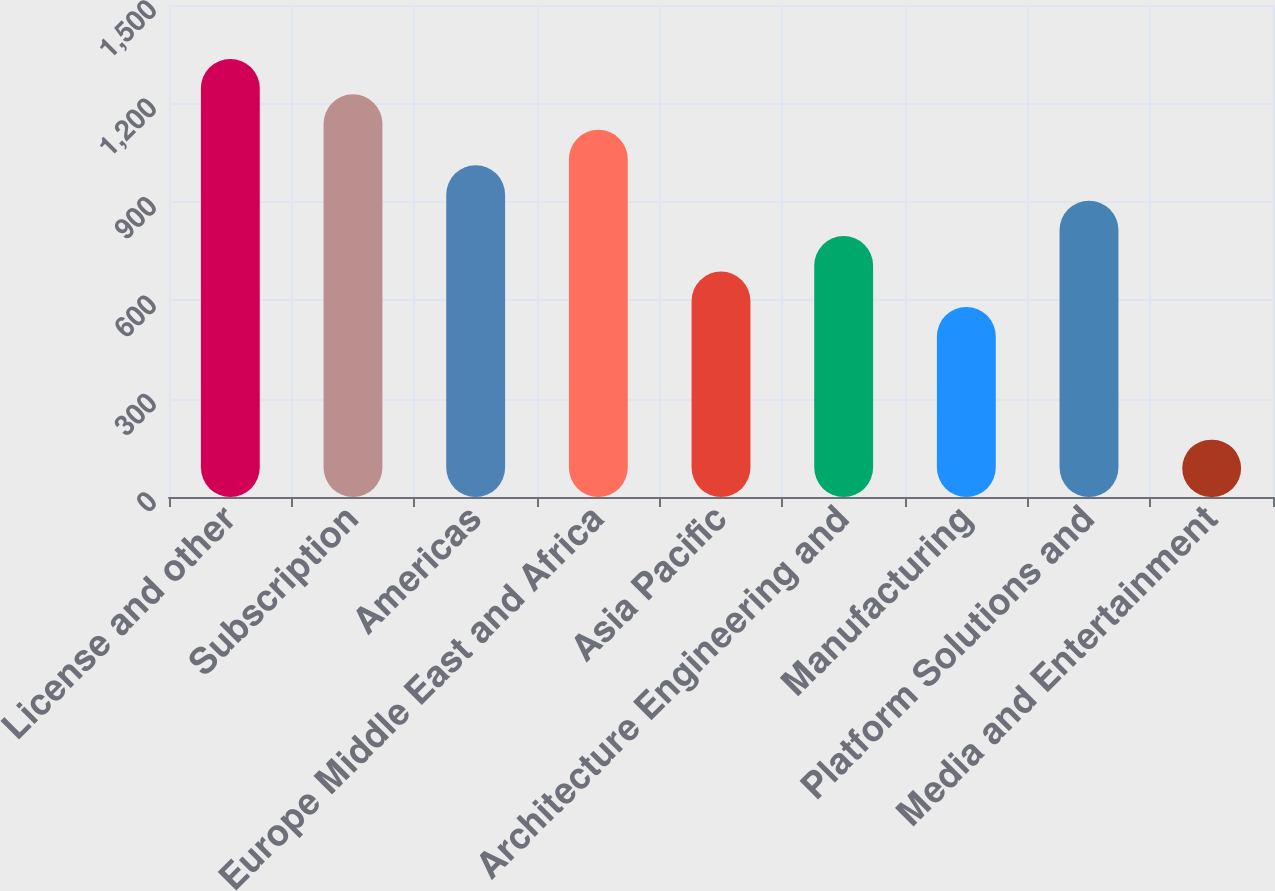Convert chart. <chart><loc_0><loc_0><loc_500><loc_500><bar_chart><fcel>License and other<fcel>Subscription<fcel>Americas<fcel>Europe Middle East and Africa<fcel>Asia Pacific<fcel>Architecture Engineering and<fcel>Manufacturing<fcel>Platform Solutions and<fcel>Media and Entertainment<nl><fcel>1335.54<fcel>1227.52<fcel>1011.48<fcel>1119.5<fcel>687.42<fcel>795.44<fcel>579.4<fcel>903.46<fcel>174.7<nl></chart> 